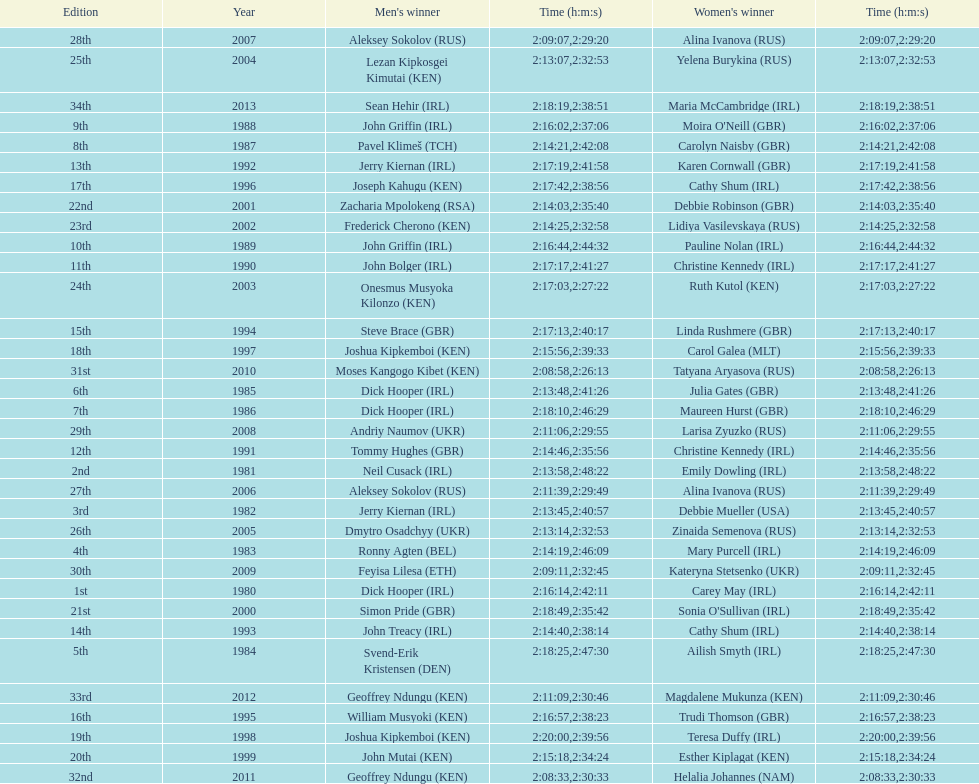Who won at least 3 times in the mens? Dick Hooper (IRL). 